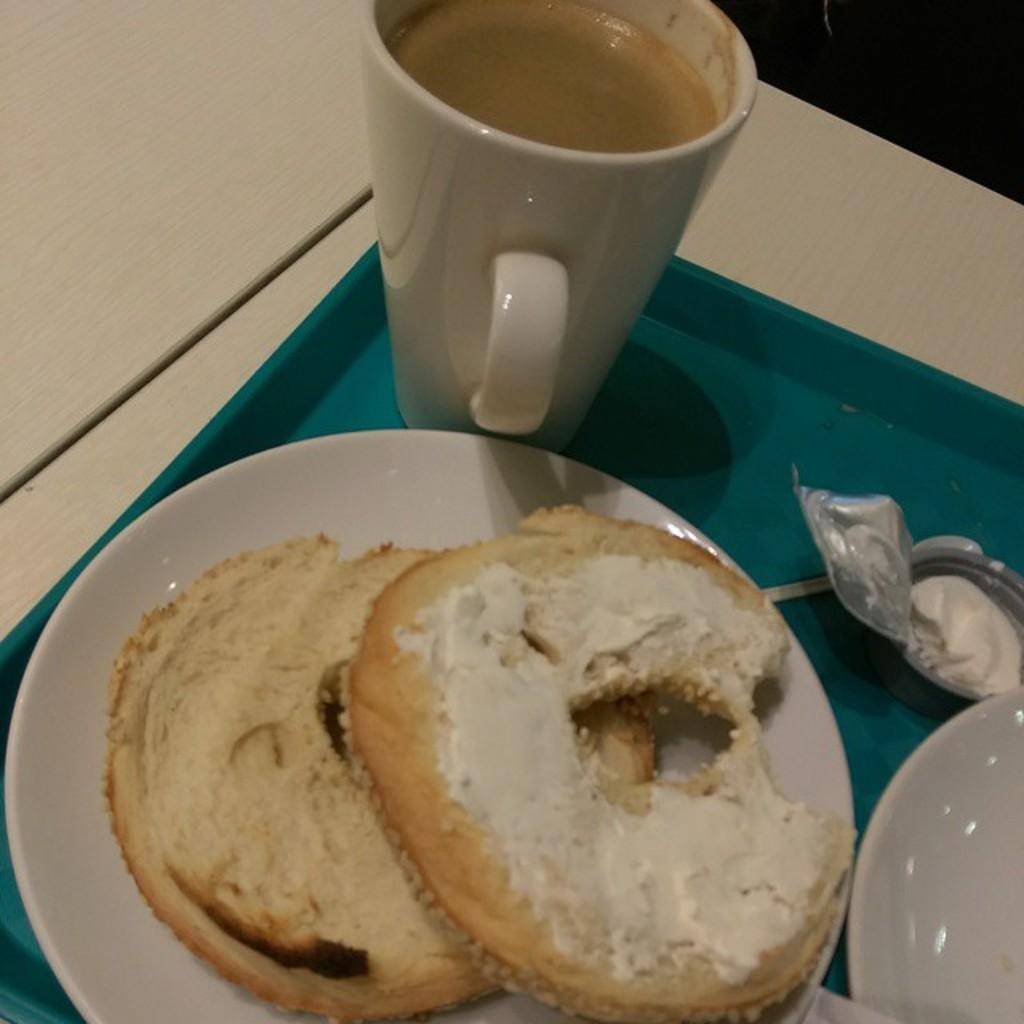Where was the image taken? The image is taken indoors. What furniture is visible in the image? There is a table in the image. What is placed on the table? There is a tray on the table. What is on the tray? There is a cup with coffee, a spoon, a plate, and another plate with a food item on the tray. What type of stone can be seen on the table in the image? There is no stone present on the table in the image. How many points does the cup with coffee have in the image? The cup with coffee does not have any points; it is a round object. 